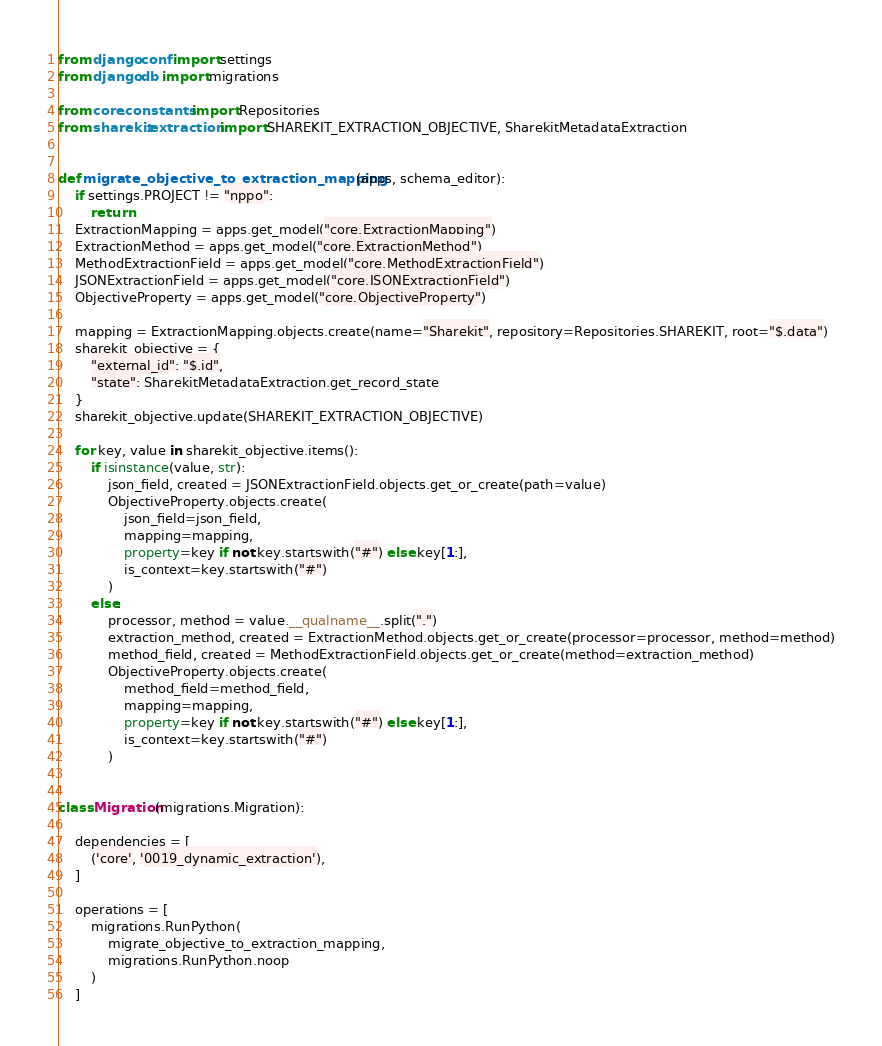Convert code to text. <code><loc_0><loc_0><loc_500><loc_500><_Python_>from django.conf import settings
from django.db import migrations

from core.constants import Repositories
from sharekit.extraction import SHAREKIT_EXTRACTION_OBJECTIVE, SharekitMetadataExtraction


def migrate_objective_to_extraction_mapping(apps, schema_editor):
    if settings.PROJECT != "nppo":
        return
    ExtractionMapping = apps.get_model("core.ExtractionMapping")
    ExtractionMethod = apps.get_model("core.ExtractionMethod")
    MethodExtractionField = apps.get_model("core.MethodExtractionField")
    JSONExtractionField = apps.get_model("core.JSONExtractionField")
    ObjectiveProperty = apps.get_model("core.ObjectiveProperty")

    mapping = ExtractionMapping.objects.create(name="Sharekit", repository=Repositories.SHAREKIT, root="$.data")
    sharekit_objective = {
        "external_id": "$.id",
        "state": SharekitMetadataExtraction.get_record_state
    }
    sharekit_objective.update(SHAREKIT_EXTRACTION_OBJECTIVE)

    for key, value in sharekit_objective.items():
        if isinstance(value, str):
            json_field, created = JSONExtractionField.objects.get_or_create(path=value)
            ObjectiveProperty.objects.create(
                json_field=json_field,
                mapping=mapping,
                property=key if not key.startswith("#") else key[1:],
                is_context=key.startswith("#")
            )
        else:
            processor, method = value.__qualname__.split(".")
            extraction_method, created = ExtractionMethod.objects.get_or_create(processor=processor, method=method)
            method_field, created = MethodExtractionField.objects.get_or_create(method=extraction_method)
            ObjectiveProperty.objects.create(
                method_field=method_field,
                mapping=mapping,
                property=key if not key.startswith("#") else key[1:],
                is_context=key.startswith("#")
            )


class Migration(migrations.Migration):

    dependencies = [
        ('core', '0019_dynamic_extraction'),
    ]

    operations = [
        migrations.RunPython(
            migrate_objective_to_extraction_mapping,
            migrations.RunPython.noop
        )
    ]
</code> 